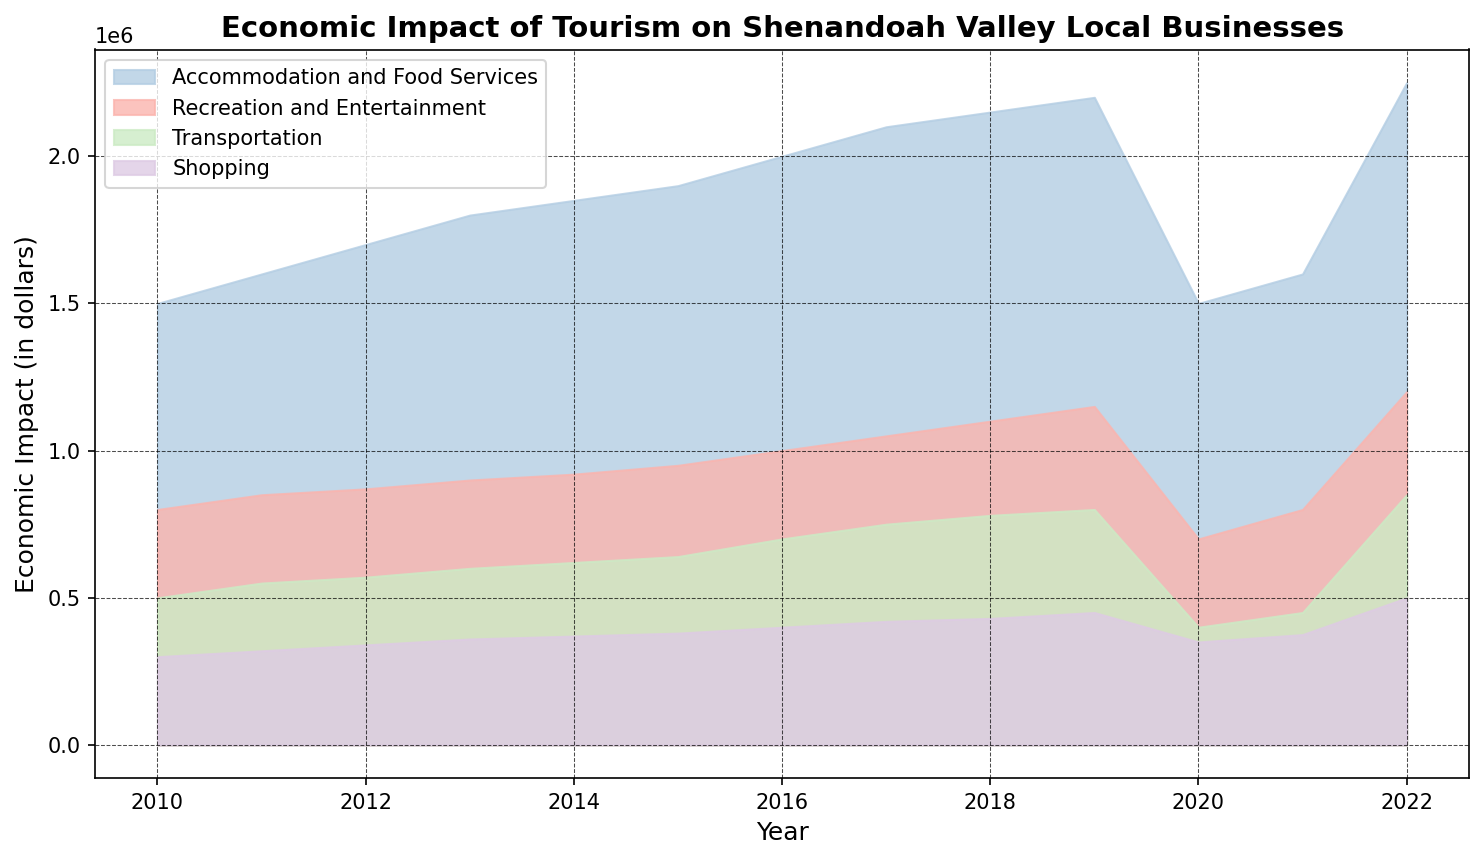What is the overall trend for the 'Accommodation and Food Services' sector from 2010 to 2022? From 2010 to 2022, the 'Accommodation and Food Services' sector shows a general increasing trend with a dip in 2020 followed by a recovery. This trend is visible as the area representing this sector gradually rises over the years, showing increased economic impact except for the noticeable dip in 2020.
Answer: Increasing Which sector shows the largest difference in economic impact between the years 2018 and 2020? To determine the sector with the largest difference, we compare the heights of the graphs for each sector between the years 2018 and 2020. 'Accommodation and Food Services' sector shows the largest difference, with a noticeable dip in the 2020 value compared to 2018.
Answer: Accommodation and Food Services In which year did the 'Shopping' sector have the highest economic impact? Observing the height of the area for the 'Shopping' sector, the peak can be seen in the year 2022. The height of the 'Shopping' area in 2022 is higher than in any other year.
Answer: 2022 How did the total economic impact of tourism change from 2010 to 2022? The trend for the total economic impact, represented by the cumulative height of all sectors combined, shows a general increase from 2010 to 2022 with a noticeable drop in 2020 followed by a subsequent recovery.
Answer: Increased What were the combined economic impacts of the 'Recreation and Entertainment' and 'Transportation' sectors in 2015? To find the combined impact, we sum the economic impacts for the 'Recreation and Entertainment' and 'Transportation' sectors in 2015: 950000 (Recreation and Entertainment) + 640000 (Transportation). Thus, the combined impact is 1590000.
Answer: 1590000 Which sector contributed the least to the total economic impact in 2020? Observing the areas representing each sector in 2020, the 'Shopping' sector has the smallest area, indicating it had the least economic impact that year.
Answer: Shopping In which year did the 'Transportation' sector see the greatest increase in economic impact compared to the previous year? By comparing the height of the 'Transportation' sector between consecutive years, the biggest increase is observed between 2016 and 2017.
Answer: 2017 Did any sector surpass an economic impact of 2 million dollars before 2016? Observing the areas representing each sector up to 2016, no individual sector surpassed an economic impact of 2 million dollars before 2016. The 'Accommodation and Food Services' sector first surpassed 2 million dollars in 2016.
Answer: No 